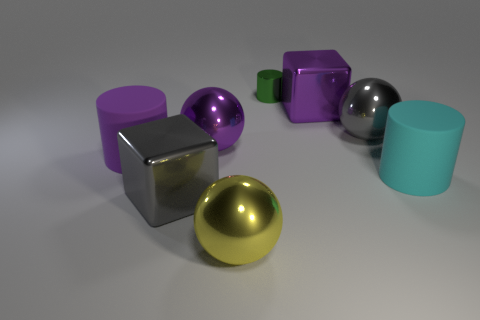Add 1 big purple cubes. How many objects exist? 9 Subtract all spheres. How many objects are left? 5 Subtract all large purple shiny cubes. Subtract all green cylinders. How many objects are left? 6 Add 3 green metal objects. How many green metal objects are left? 4 Add 8 purple shiny cubes. How many purple shiny cubes exist? 9 Subtract 0 red cylinders. How many objects are left? 8 